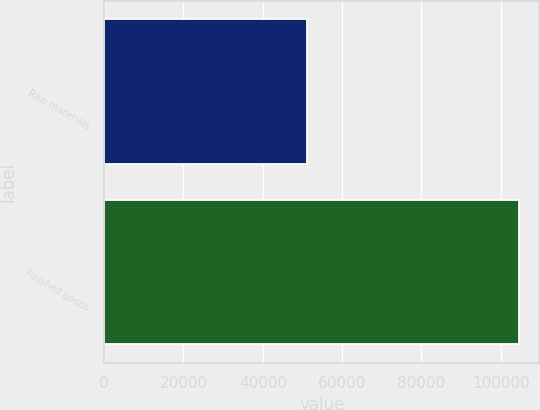<chart> <loc_0><loc_0><loc_500><loc_500><bar_chart><fcel>Raw materials<fcel>Finished goods<nl><fcel>51103<fcel>104510<nl></chart> 